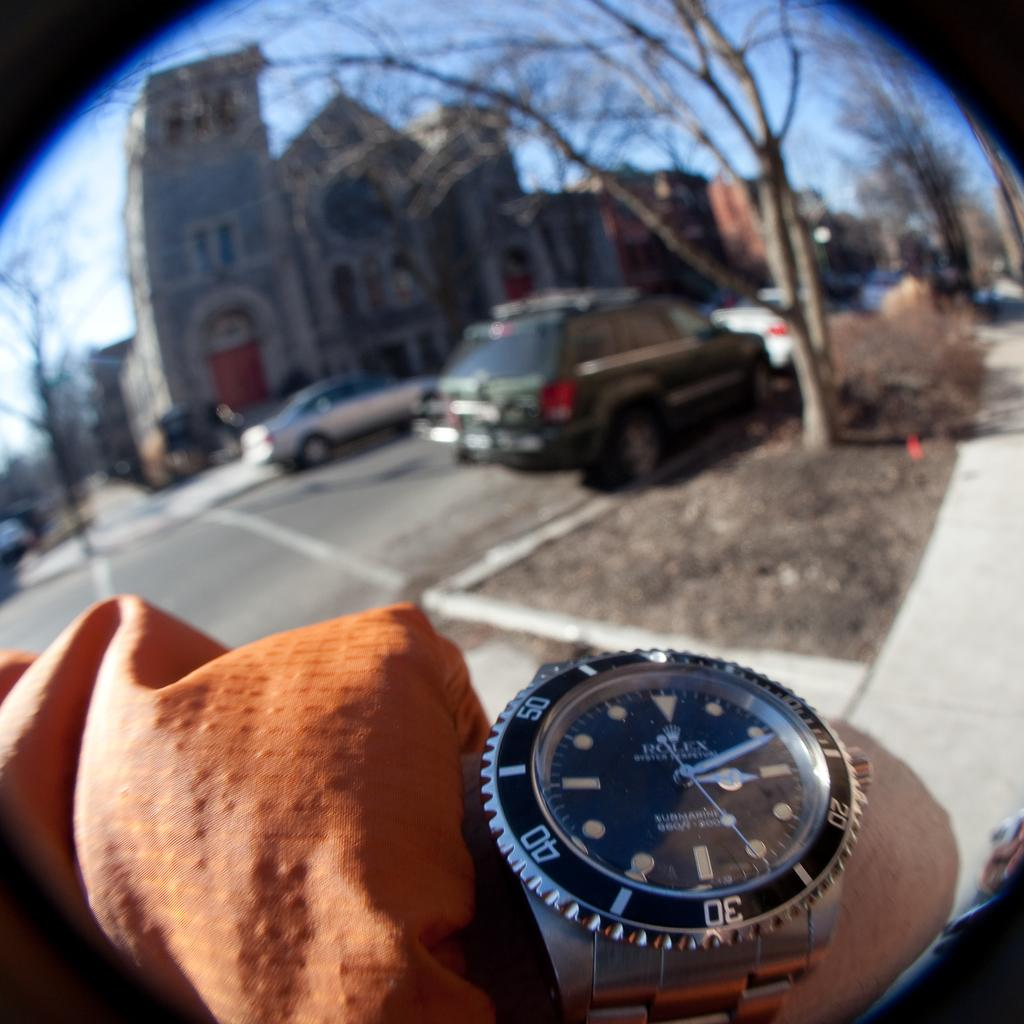<image>
Write a terse but informative summary of the picture. A Rolex watch displays the time of 3:11. 